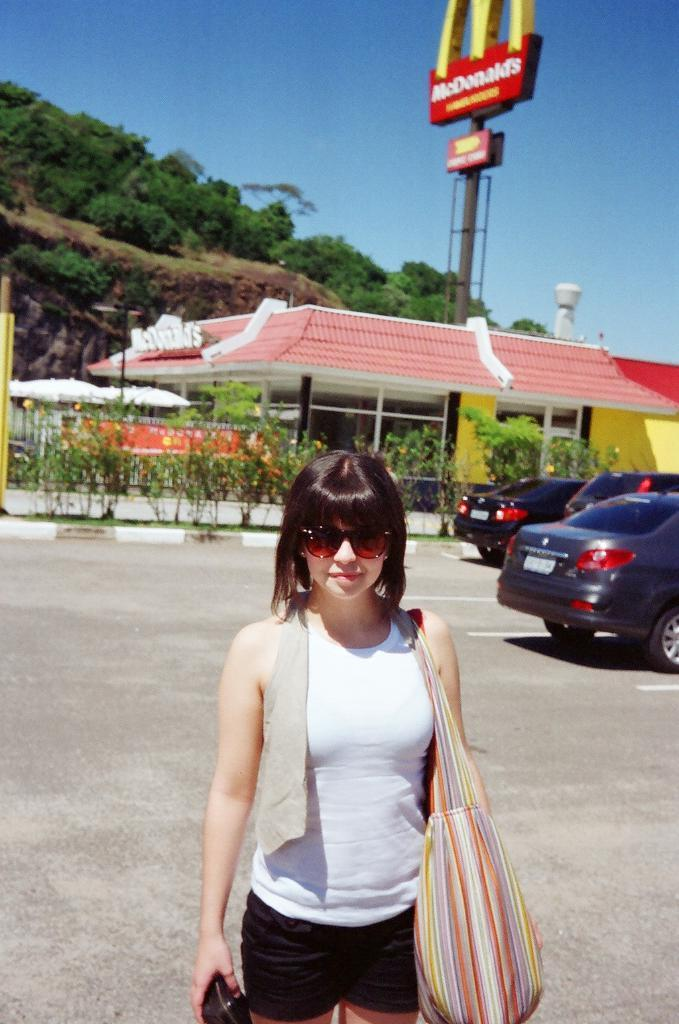Who is the main subject in the image? There is a girl in the center of the image. What can be seen in the background of the image? There are cars, umbrellas, and a McDonald's store in the background of the image. What type of environment is visible in the image? There is greenery visible in the image. What type of operation is being performed on the cattle in the image? There are no cattle present in the image, so no operation is being performed. 